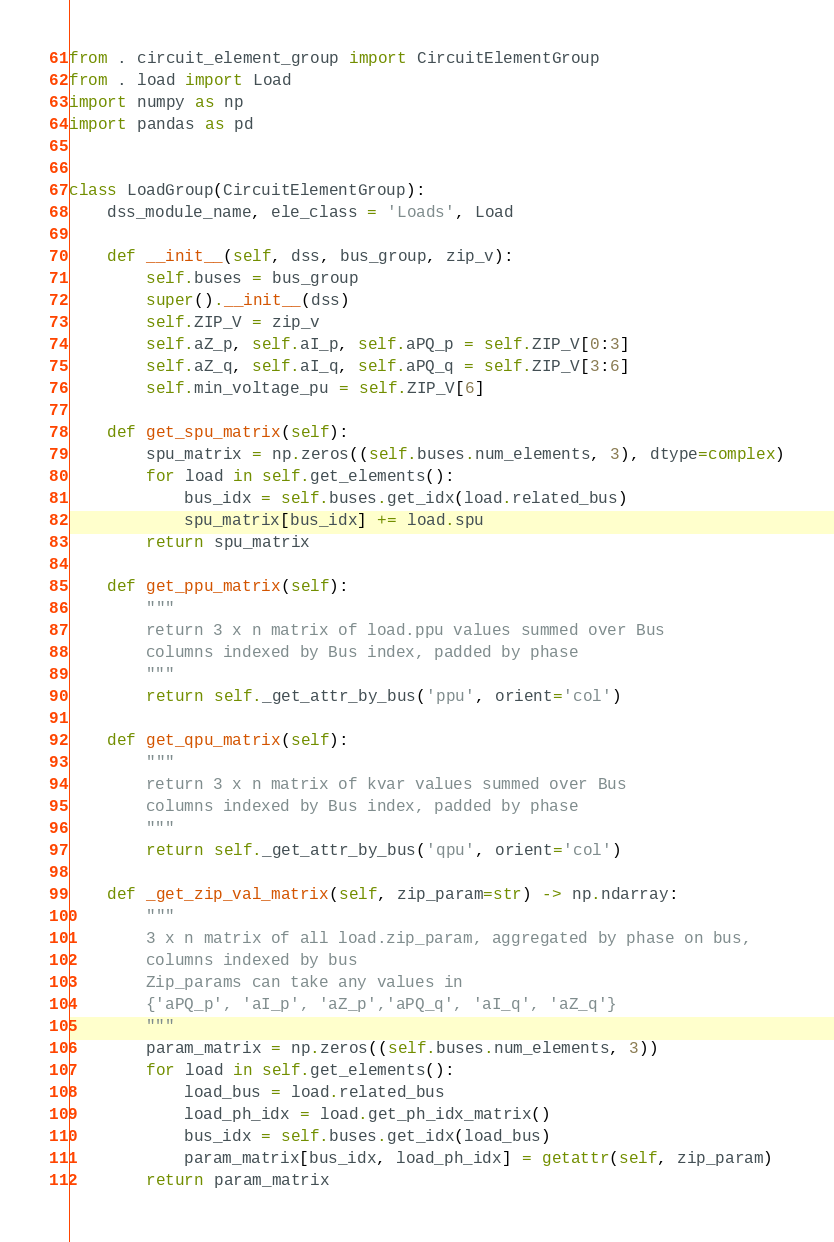Convert code to text. <code><loc_0><loc_0><loc_500><loc_500><_Python_>from . circuit_element_group import CircuitElementGroup
from . load import Load
import numpy as np
import pandas as pd


class LoadGroup(CircuitElementGroup):
    dss_module_name, ele_class = 'Loads', Load

    def __init__(self, dss, bus_group, zip_v):
        self.buses = bus_group
        super().__init__(dss)
        self.ZIP_V = zip_v
        self.aZ_p, self.aI_p, self.aPQ_p = self.ZIP_V[0:3]
        self.aZ_q, self.aI_q, self.aPQ_q = self.ZIP_V[3:6]
        self.min_voltage_pu = self.ZIP_V[6]

    def get_spu_matrix(self):
        spu_matrix = np.zeros((self.buses.num_elements, 3), dtype=complex)
        for load in self.get_elements():
            bus_idx = self.buses.get_idx(load.related_bus)
            spu_matrix[bus_idx] += load.spu
        return spu_matrix

    def get_ppu_matrix(self):
        """
        return 3 x n matrix of load.ppu values summed over Bus
        columns indexed by Bus index, padded by phase
        """
        return self._get_attr_by_bus('ppu', orient='col')

    def get_qpu_matrix(self):
        """
        return 3 x n matrix of kvar values summed over Bus
        columns indexed by Bus index, padded by phase
        """
        return self._get_attr_by_bus('qpu', orient='col')

    def _get_zip_val_matrix(self, zip_param=str) -> np.ndarray:
        """
        3 x n matrix of all load.zip_param, aggregated by phase on bus,
        columns indexed by bus
        Zip_params can take any values in
        {'aPQ_p', 'aI_p', 'aZ_p','aPQ_q', 'aI_q', 'aZ_q'}
        """
        param_matrix = np.zeros((self.buses.num_elements, 3))
        for load in self.get_elements():
            load_bus = load.related_bus
            load_ph_idx = load.get_ph_idx_matrix()
            bus_idx = self.buses.get_idx(load_bus)
            param_matrix[bus_idx, load_ph_idx] = getattr(self, zip_param)
        return param_matrix
</code> 